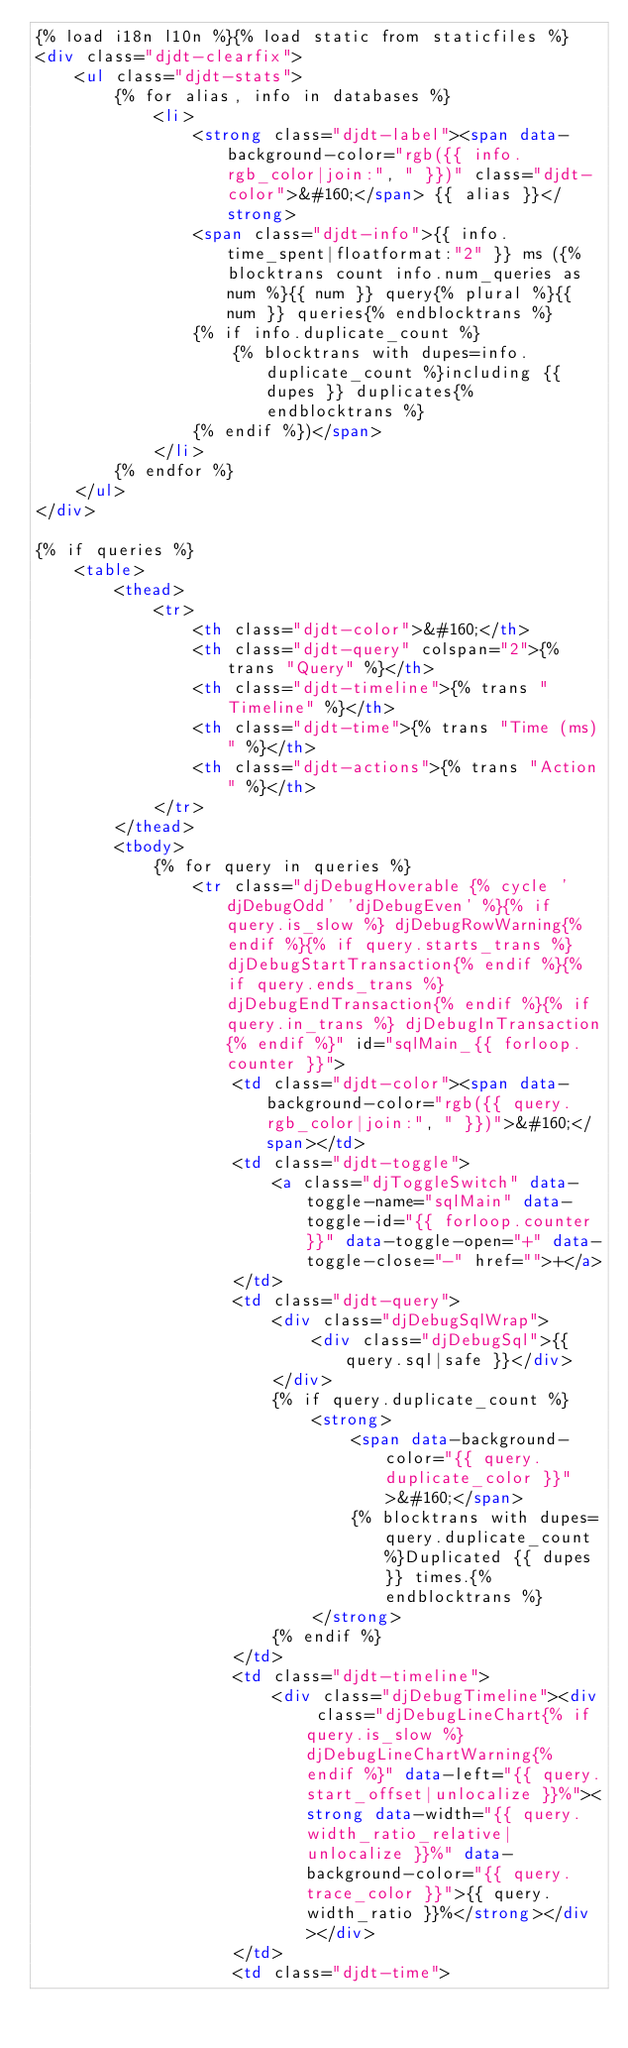Convert code to text. <code><loc_0><loc_0><loc_500><loc_500><_HTML_>{% load i18n l10n %}{% load static from staticfiles %}
<div class="djdt-clearfix">
	<ul class="djdt-stats">
		{% for alias, info in databases %}
			<li>
				<strong class="djdt-label"><span data-background-color="rgb({{ info.rgb_color|join:", " }})" class="djdt-color">&#160;</span> {{ alias }}</strong>
				<span class="djdt-info">{{ info.time_spent|floatformat:"2" }} ms ({% blocktrans count info.num_queries as num %}{{ num }} query{% plural %}{{ num }} queries{% endblocktrans %}
				{% if info.duplicate_count %}
					{% blocktrans with dupes=info.duplicate_count %}including {{ dupes }} duplicates{% endblocktrans %}
				{% endif %})</span>
			</li>
		{% endfor %}
	</ul>
</div>

{% if queries %}
	<table>
		<thead>
			<tr>
				<th class="djdt-color">&#160;</th>
				<th class="djdt-query" colspan="2">{% trans "Query" %}</th>
				<th class="djdt-timeline">{% trans "Timeline" %}</th>
				<th class="djdt-time">{% trans "Time (ms)" %}</th>
				<th class="djdt-actions">{% trans "Action" %}</th>
			</tr>
		</thead>
		<tbody>
			{% for query in queries %}
				<tr class="djDebugHoverable {% cycle 'djDebugOdd' 'djDebugEven' %}{% if query.is_slow %} djDebugRowWarning{% endif %}{% if query.starts_trans %} djDebugStartTransaction{% endif %}{% if query.ends_trans %} djDebugEndTransaction{% endif %}{% if query.in_trans %} djDebugInTransaction{% endif %}" id="sqlMain_{{ forloop.counter }}">
					<td class="djdt-color"><span data-background-color="rgb({{ query.rgb_color|join:", " }})">&#160;</span></td>
					<td class="djdt-toggle">
						<a class="djToggleSwitch" data-toggle-name="sqlMain" data-toggle-id="{{ forloop.counter }}" data-toggle-open="+" data-toggle-close="-" href="">+</a>
					</td>
					<td class="djdt-query">
						<div class="djDebugSqlWrap">
							<div class="djDebugSql">{{ query.sql|safe }}</div>
						</div>
						{% if query.duplicate_count %}
							<strong>
								<span data-background-color="{{ query.duplicate_color }}">&#160;</span>
								{% blocktrans with dupes=query.duplicate_count %}Duplicated {{ dupes }} times.{% endblocktrans %}
							</strong>
						{% endif %}
					</td>
					<td class="djdt-timeline">
						<div class="djDebugTimeline"><div class="djDebugLineChart{% if query.is_slow %} djDebugLineChartWarning{% endif %}" data-left="{{ query.start_offset|unlocalize }}%"><strong data-width="{{ query.width_ratio_relative|unlocalize }}%" data-background-color="{{ query.trace_color }}">{{ query.width_ratio }}%</strong></div></div>
					</td>
					<td class="djdt-time"></code> 